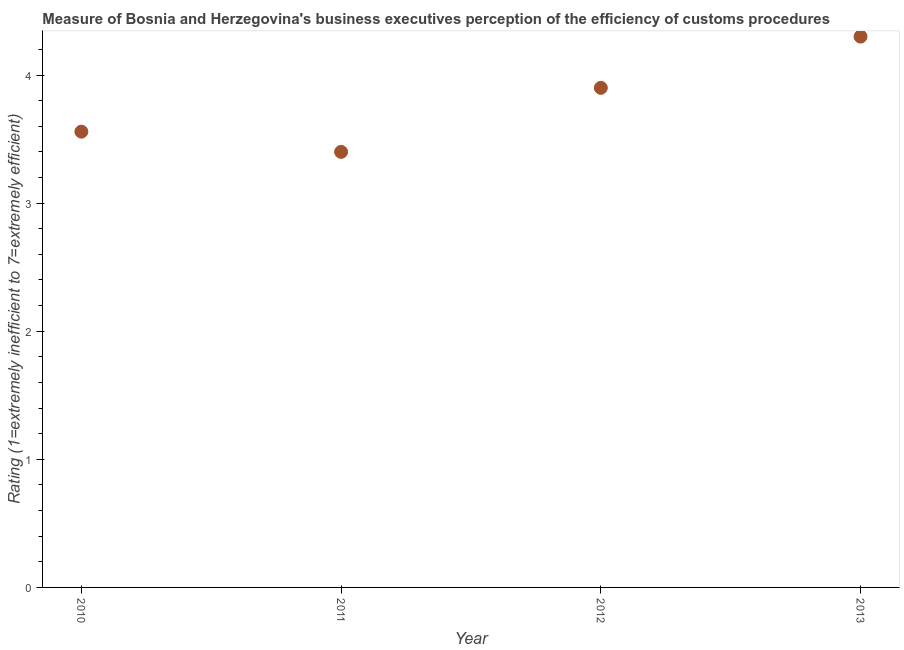What is the rating measuring burden of customs procedure in 2013?
Give a very brief answer. 4.3. Across all years, what is the minimum rating measuring burden of customs procedure?
Make the answer very short. 3.4. What is the sum of the rating measuring burden of customs procedure?
Your response must be concise. 15.16. What is the difference between the rating measuring burden of customs procedure in 2010 and 2011?
Your answer should be very brief. 0.16. What is the average rating measuring burden of customs procedure per year?
Make the answer very short. 3.79. What is the median rating measuring burden of customs procedure?
Offer a very short reply. 3.73. Do a majority of the years between 2010 and 2012 (inclusive) have rating measuring burden of customs procedure greater than 2.2 ?
Make the answer very short. Yes. What is the ratio of the rating measuring burden of customs procedure in 2012 to that in 2013?
Your response must be concise. 0.91. Is the rating measuring burden of customs procedure in 2010 less than that in 2012?
Offer a terse response. Yes. Is the difference between the rating measuring burden of customs procedure in 2010 and 2011 greater than the difference between any two years?
Ensure brevity in your answer.  No. What is the difference between the highest and the second highest rating measuring burden of customs procedure?
Your answer should be compact. 0.4. Is the sum of the rating measuring burden of customs procedure in 2010 and 2013 greater than the maximum rating measuring burden of customs procedure across all years?
Keep it short and to the point. Yes. What is the difference between the highest and the lowest rating measuring burden of customs procedure?
Offer a very short reply. 0.9. In how many years, is the rating measuring burden of customs procedure greater than the average rating measuring burden of customs procedure taken over all years?
Your response must be concise. 2. What is the difference between two consecutive major ticks on the Y-axis?
Provide a succinct answer. 1. Are the values on the major ticks of Y-axis written in scientific E-notation?
Your response must be concise. No. Does the graph contain any zero values?
Keep it short and to the point. No. Does the graph contain grids?
Offer a very short reply. No. What is the title of the graph?
Your answer should be compact. Measure of Bosnia and Herzegovina's business executives perception of the efficiency of customs procedures. What is the label or title of the X-axis?
Ensure brevity in your answer.  Year. What is the label or title of the Y-axis?
Your answer should be very brief. Rating (1=extremely inefficient to 7=extremely efficient). What is the Rating (1=extremely inefficient to 7=extremely efficient) in 2010?
Give a very brief answer. 3.56. What is the Rating (1=extremely inefficient to 7=extremely efficient) in 2011?
Ensure brevity in your answer.  3.4. What is the Rating (1=extremely inefficient to 7=extremely efficient) in 2013?
Ensure brevity in your answer.  4.3. What is the difference between the Rating (1=extremely inefficient to 7=extremely efficient) in 2010 and 2011?
Give a very brief answer. 0.16. What is the difference between the Rating (1=extremely inefficient to 7=extremely efficient) in 2010 and 2012?
Your answer should be very brief. -0.34. What is the difference between the Rating (1=extremely inefficient to 7=extremely efficient) in 2010 and 2013?
Your answer should be compact. -0.74. What is the difference between the Rating (1=extremely inefficient to 7=extremely efficient) in 2011 and 2012?
Make the answer very short. -0.5. What is the difference between the Rating (1=extremely inefficient to 7=extremely efficient) in 2011 and 2013?
Offer a very short reply. -0.9. What is the difference between the Rating (1=extremely inefficient to 7=extremely efficient) in 2012 and 2013?
Provide a short and direct response. -0.4. What is the ratio of the Rating (1=extremely inefficient to 7=extremely efficient) in 2010 to that in 2011?
Provide a succinct answer. 1.05. What is the ratio of the Rating (1=extremely inefficient to 7=extremely efficient) in 2010 to that in 2012?
Your answer should be compact. 0.91. What is the ratio of the Rating (1=extremely inefficient to 7=extremely efficient) in 2010 to that in 2013?
Make the answer very short. 0.83. What is the ratio of the Rating (1=extremely inefficient to 7=extremely efficient) in 2011 to that in 2012?
Offer a terse response. 0.87. What is the ratio of the Rating (1=extremely inefficient to 7=extremely efficient) in 2011 to that in 2013?
Offer a terse response. 0.79. What is the ratio of the Rating (1=extremely inefficient to 7=extremely efficient) in 2012 to that in 2013?
Your response must be concise. 0.91. 